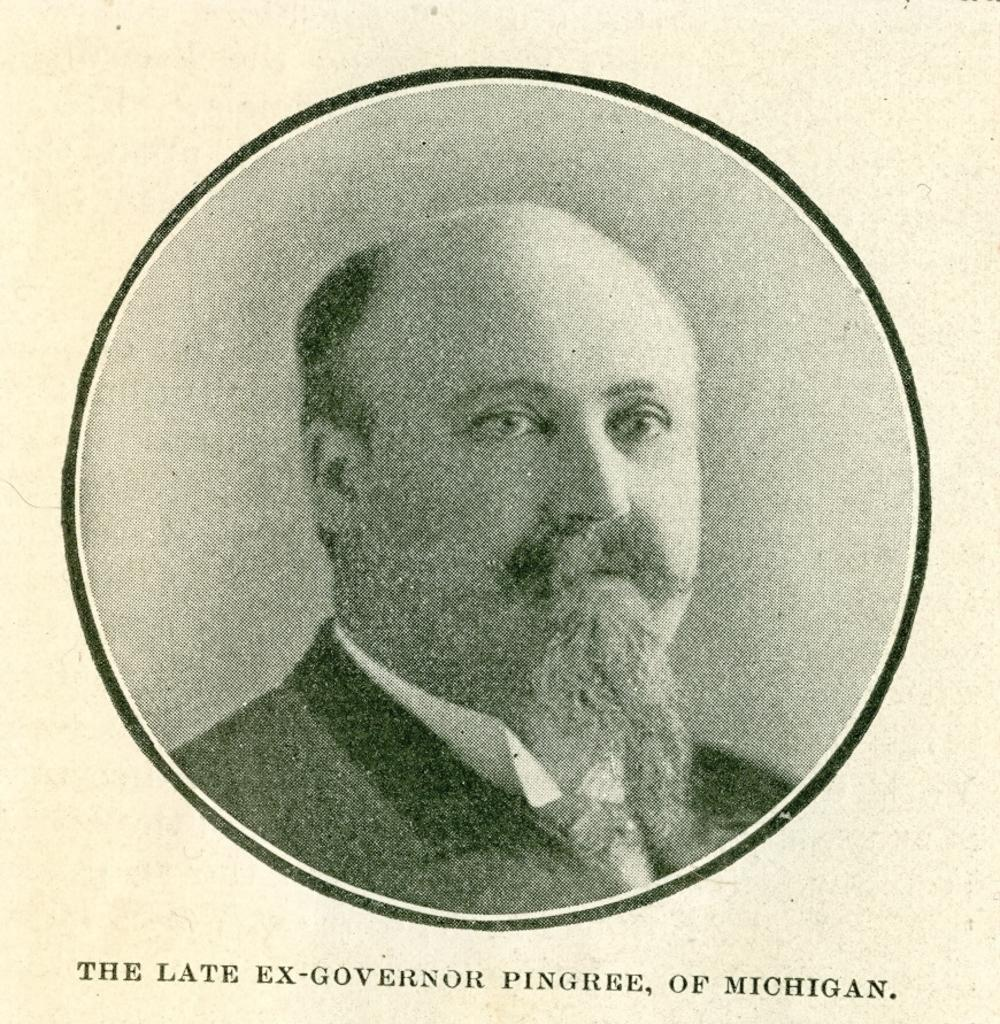What is the main subject of the picture? The main subject of the picture is an image of a person. How is the image of the person presented in the picture? The image of the person is in a circle shape. What else can be seen in the picture besides the image of the person? There is text written below the circle. What type of sound can be heard coming from the spark in the image? There is no spark or sound present in the image; it features an image of a person in a circle shape with text below it. 